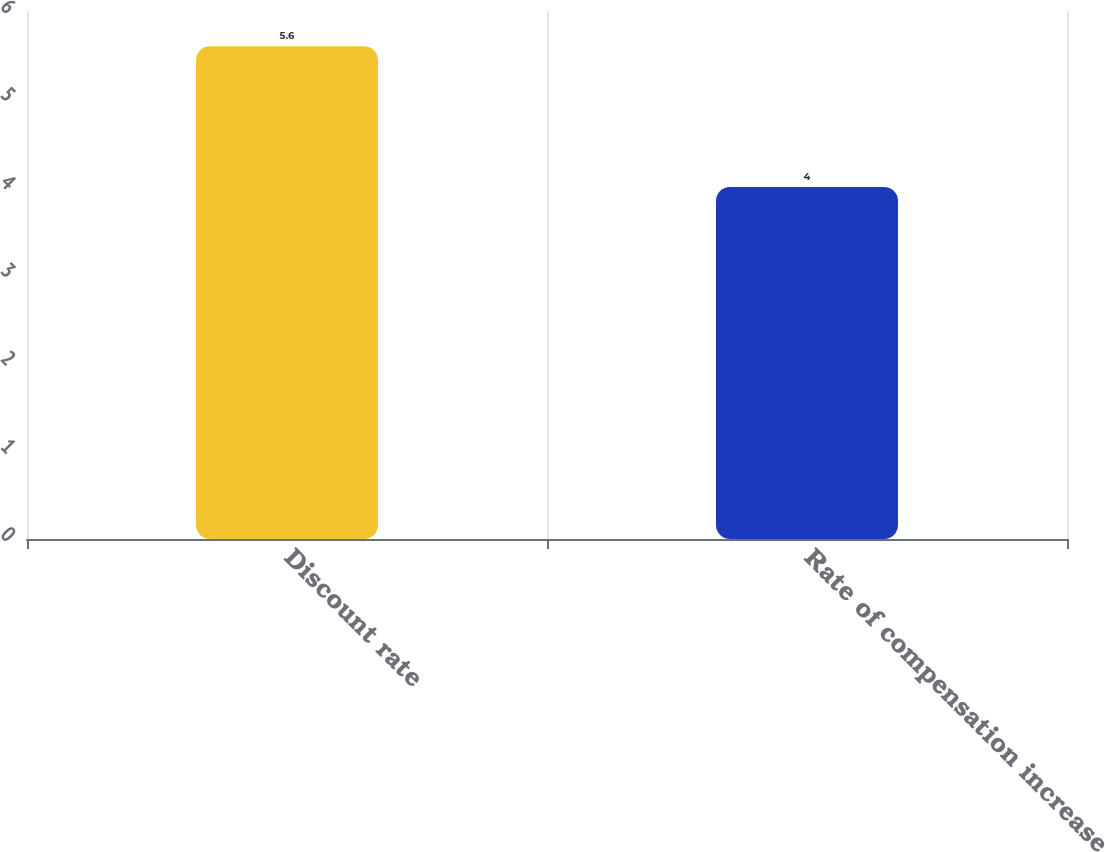<chart> <loc_0><loc_0><loc_500><loc_500><bar_chart><fcel>Discount rate<fcel>Rate of compensation increase<nl><fcel>5.6<fcel>4<nl></chart> 